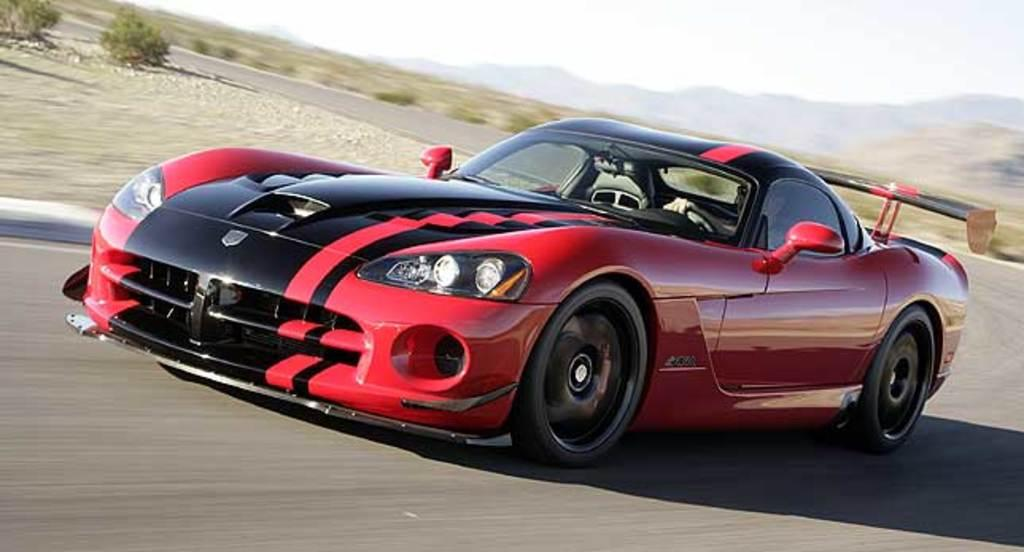What is the main subject of the image? The main subject of the image is a car. What is the car doing in the image? The car is moving on the road in the image. Can you describe the person inside the car? There is a person sitting inside the car. What can be seen in the background of the image? There are mountains and plants in the background of the image. What type of wristwatch is the person wearing in the image? There is no wristwatch visible in the image, as the person's wrist is not shown. 